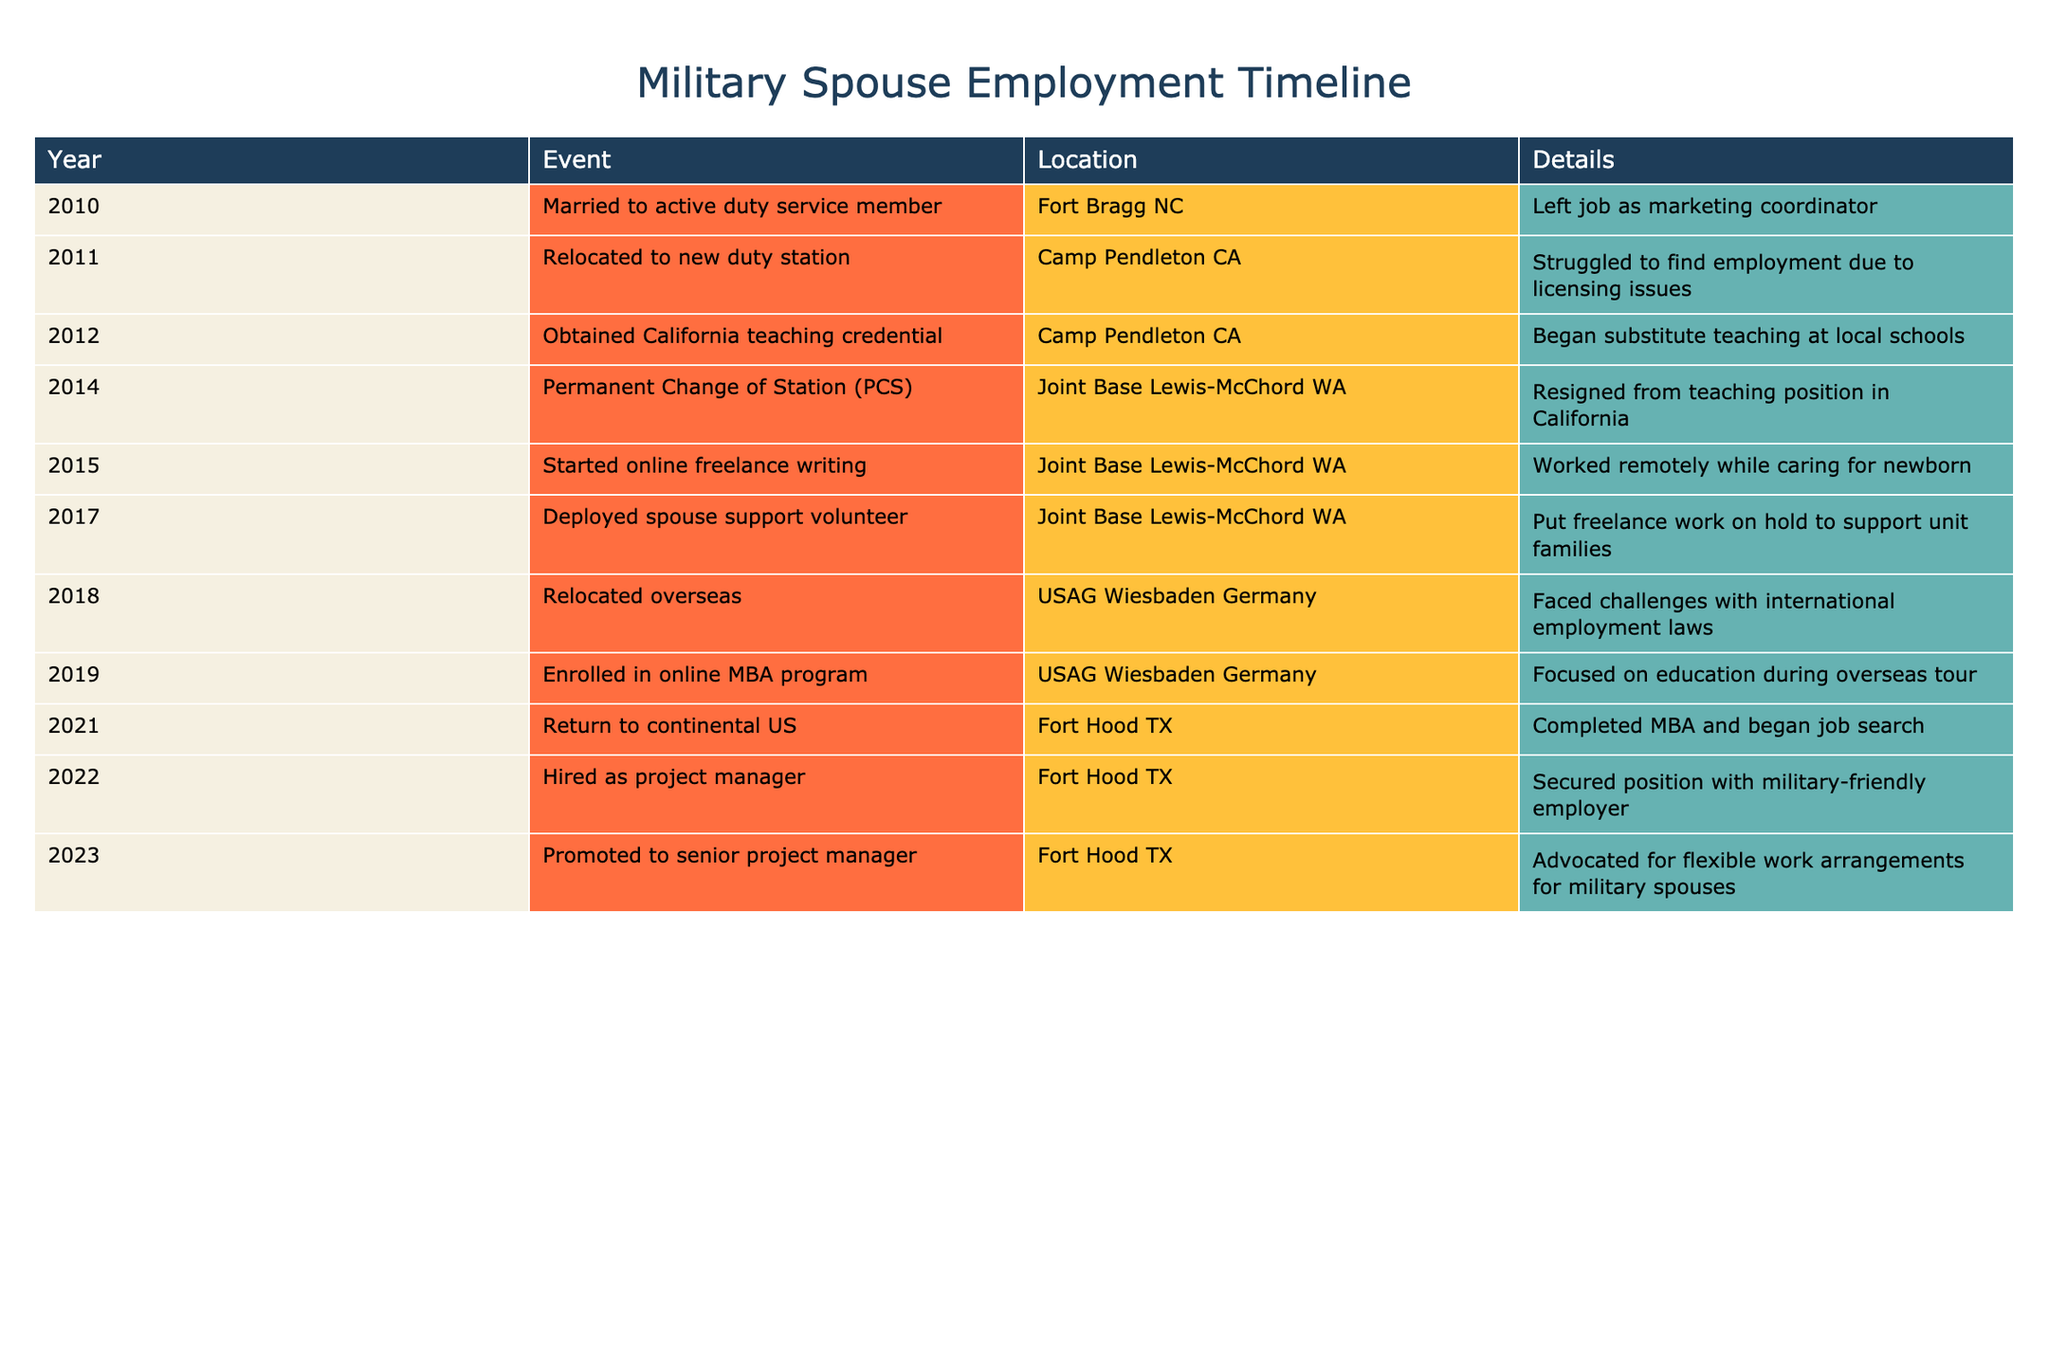What year did the spouse start online freelance writing? The timeline indicates that the spouse started online freelance writing in the year 2015. This is directly stated in the event for that year.
Answer: 2015 How many duty stations did the spouse relocate to during the timeline? The spouse relocated to three distinct duty stations: Camp Pendleton CA, Joint Base Lewis-McChord WA, and USAG Wiesbaden Germany. Each of these relocations is mentioned in the events.
Answer: 3 What is the time gap between the spouse obtaining the California teaching credential and starting online freelance writing? The spouse obtained the teaching credential in 2012 and started online freelance writing in 2015. The time gap is 2015 - 2012 = 3 years.
Answer: 3 years Did the spouse face challenges with employment while overseas in Germany? Yes, the data states that the spouse faced challenges with international employment laws while living in USAG Wiesbaden Germany.
Answer: Yes What was the spouse's employment situation during their stay at Joint Base Lewis-McChord WA? At Joint Base Lewis-McChord WA, the spouse worked remotely as a freelance writer while caring for a newborn, then paused the freelance work to support unit families as a deployed spouse support volunteer. This involved two distinct employment situations.
Answer: Two situations How many years did the spouse remain in the Fort Hood TX location before being promoted? The spouse returned to Fort Hood TX in 2021 and was promoted in 2023. Therefore, the duration in Fort Hood before the promotion was 2023 - 2021 = 2 years.
Answer: 2 years Was the spouse actively searching for employment immediately after completing the MBA? Yes, the spouse began a job search right after completing the MBA in 2021, as indicated in that year's event details.
Answer: Yes What significant educational milestone did the spouse achieve during their time in Germany? While stationed in Germany, the spouse enrolled in an online MBA program in 2019, which is a significant educational milestone mentioned in the timeline.
Answer: MBA enrollment How many events indicate voluntary support roles rather than direct employment? There are two instances: the spouse was a deployed spouse support volunteer in 2017 and faced challenges with work while caring for a newborn in 2015. Both indicate support roles rather than traditional employment.
Answer: 2 events 